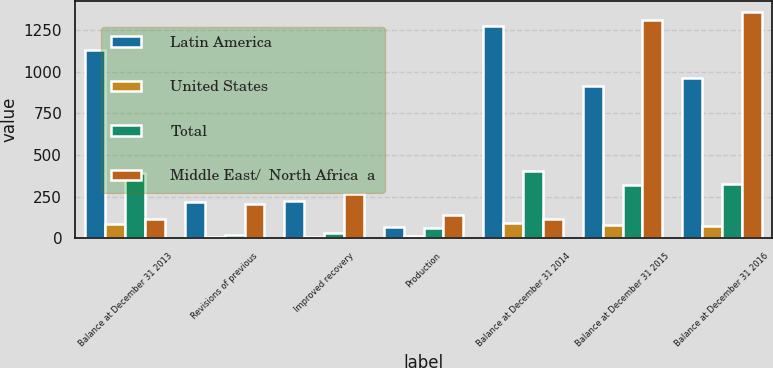<chart> <loc_0><loc_0><loc_500><loc_500><stacked_bar_chart><ecel><fcel>Balance at December 31 2013<fcel>Revisions of previous<fcel>Improved recovery<fcel>Production<fcel>Balance at December 31 2014<fcel>Balance at December 31 2015<fcel>Balance at December 31 2016<nl><fcel>Latin America<fcel>1131<fcel>220<fcel>224<fcel>67<fcel>1273<fcel>915<fcel>960<nl><fcel>United States<fcel>88<fcel>10<fcel>9<fcel>11<fcel>92<fcel>77<fcel>71<nl><fcel>Total<fcel>394<fcel>22<fcel>32<fcel>63<fcel>405<fcel>317<fcel>326<nl><fcel>Middle East/  North Africa  a<fcel>116.5<fcel>208<fcel>265<fcel>141<fcel>116.5<fcel>1309<fcel>1357<nl></chart> 